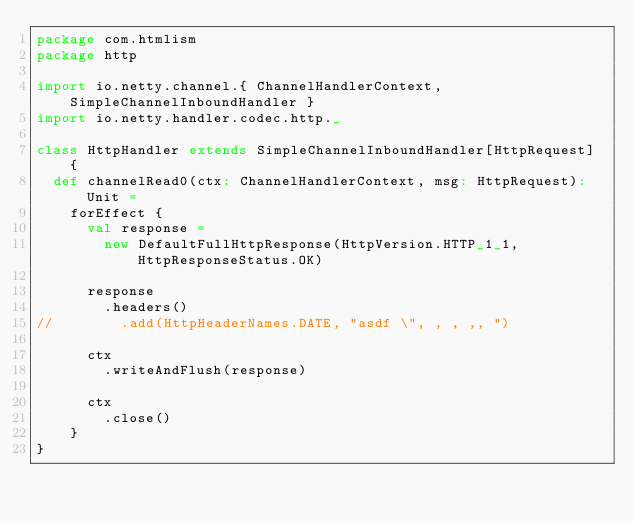Convert code to text. <code><loc_0><loc_0><loc_500><loc_500><_Scala_>package com.htmlism
package http

import io.netty.channel.{ ChannelHandlerContext, SimpleChannelInboundHandler }
import io.netty.handler.codec.http._

class HttpHandler extends SimpleChannelInboundHandler[HttpRequest] {
  def channelRead0(ctx: ChannelHandlerContext, msg: HttpRequest): Unit =
    forEffect {
      val response =
        new DefaultFullHttpResponse(HttpVersion.HTTP_1_1, HttpResponseStatus.OK)

      response
        .headers()
//        .add(HttpHeaderNames.DATE, "asdf \", , , ,, ")

      ctx
        .writeAndFlush(response)

      ctx
        .close()
    }
}
</code> 